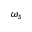Convert formula to latex. <formula><loc_0><loc_0><loc_500><loc_500>\omega _ { s }</formula> 